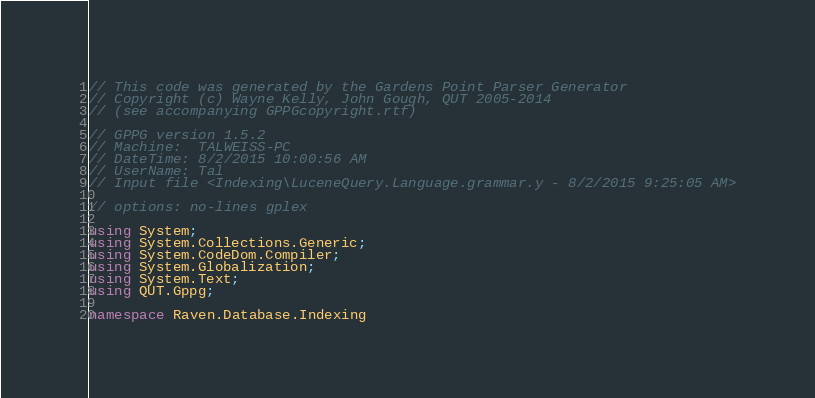<code> <loc_0><loc_0><loc_500><loc_500><_C#_>// This code was generated by the Gardens Point Parser Generator
// Copyright (c) Wayne Kelly, John Gough, QUT 2005-2014
// (see accompanying GPPGcopyright.rtf)

// GPPG version 1.5.2
// Machine:  TALWEISS-PC
// DateTime: 8/2/2015 10:00:56 AM
// UserName: Tal
// Input file <Indexing\LuceneQuery.Language.grammar.y - 8/2/2015 9:25:05 AM>

// options: no-lines gplex

using System;
using System.Collections.Generic;
using System.CodeDom.Compiler;
using System.Globalization;
using System.Text;
using QUT.Gppg;

namespace Raven.Database.Indexing</code> 